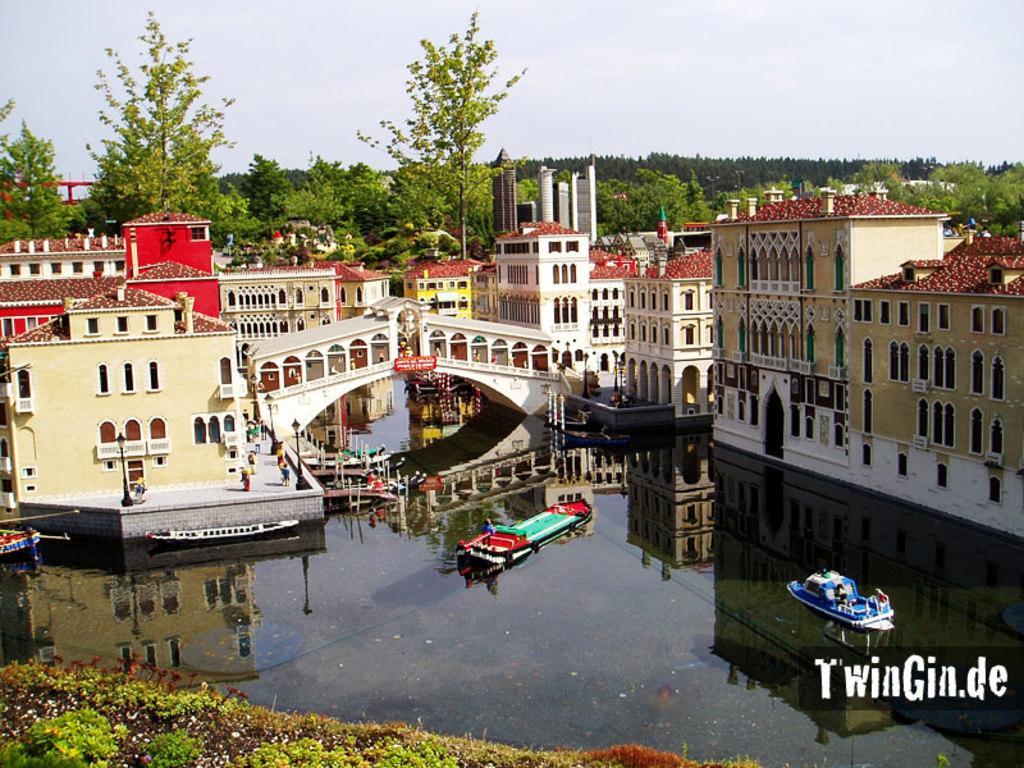Could you give a brief overview of what you see in this image? In this image we can see boats on the water, few buildings, a bridge, few people on the road, light poles, trees and the sky in the background. 